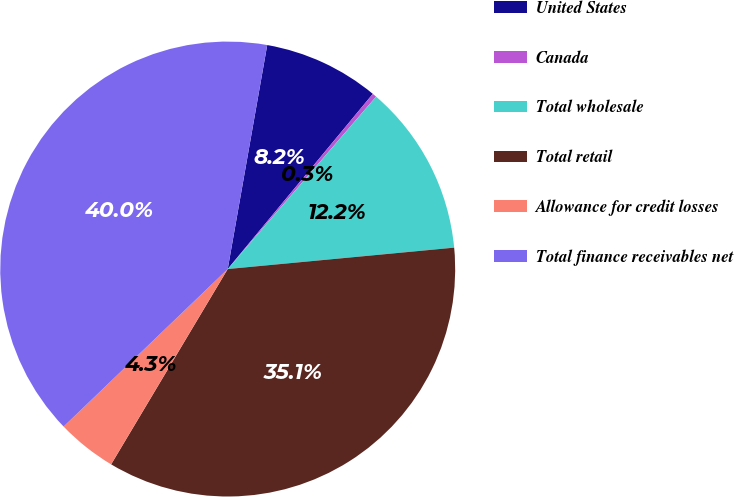Convert chart to OTSL. <chart><loc_0><loc_0><loc_500><loc_500><pie_chart><fcel>United States<fcel>Canada<fcel>Total wholesale<fcel>Total retail<fcel>Allowance for credit losses<fcel>Total finance receivables net<nl><fcel>8.23%<fcel>0.3%<fcel>12.19%<fcel>35.06%<fcel>4.26%<fcel>39.95%<nl></chart> 